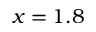Convert formula to latex. <formula><loc_0><loc_0><loc_500><loc_500>x = 1 . 8</formula> 